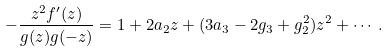Convert formula to latex. <formula><loc_0><loc_0><loc_500><loc_500>- \frac { z ^ { 2 } f ^ { \prime } ( z ) } { g ( z ) g ( - z ) } = 1 + 2 a _ { 2 } z + ( 3 a _ { 3 } - 2 g _ { 3 } + g _ { 2 } ^ { 2 } ) z ^ { 2 } + \cdots .</formula> 